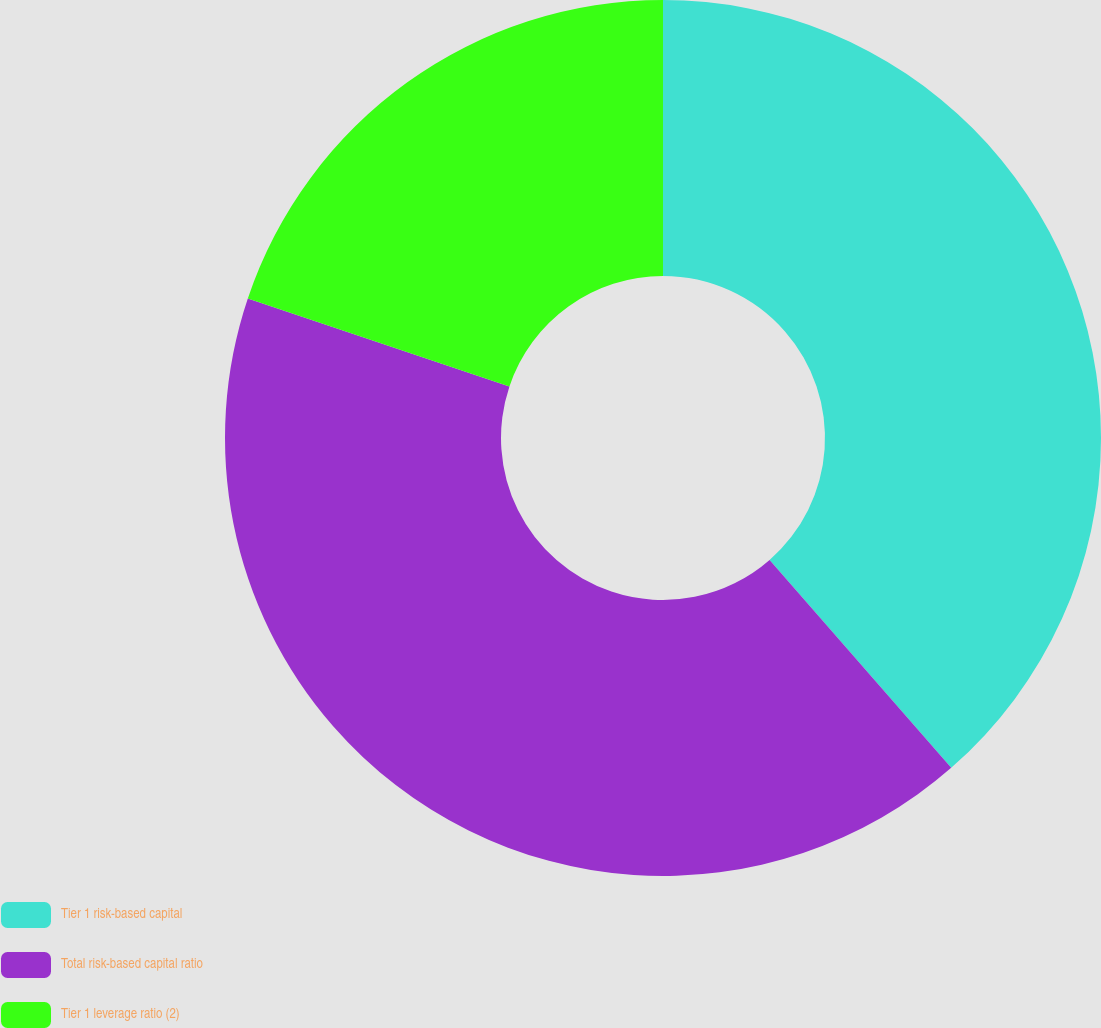Convert chart. <chart><loc_0><loc_0><loc_500><loc_500><pie_chart><fcel>Tier 1 risk-based capital<fcel>Total risk-based capital ratio<fcel>Tier 1 leverage ratio (2)<nl><fcel>38.57%<fcel>41.59%<fcel>19.84%<nl></chart> 